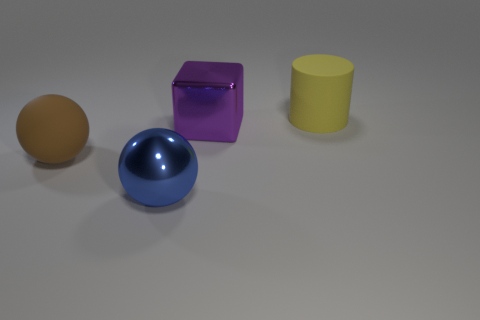Is the number of large yellow rubber cylinders less than the number of objects?
Offer a terse response. Yes. There is a large matte cylinder; are there any brown matte objects in front of it?
Your response must be concise. Yes. There is a big object that is both in front of the yellow rubber cylinder and to the right of the large blue metal thing; what is its shape?
Make the answer very short. Cube. Are there any other blue shiny things of the same shape as the blue thing?
Provide a succinct answer. No. Is the size of the rubber thing that is left of the yellow rubber thing the same as the object behind the cube?
Offer a very short reply. Yes. Are there more yellow metallic cylinders than rubber objects?
Offer a very short reply. No. What number of big cubes are the same material as the blue object?
Your answer should be very brief. 1. Is the large brown object the same shape as the big blue thing?
Provide a short and direct response. Yes. There is a rubber thing that is left of the matte thing that is behind the rubber thing that is in front of the yellow matte cylinder; how big is it?
Ensure brevity in your answer.  Large. There is a big metallic thing on the right side of the big blue thing; is there a big rubber ball that is to the left of it?
Your response must be concise. Yes. 